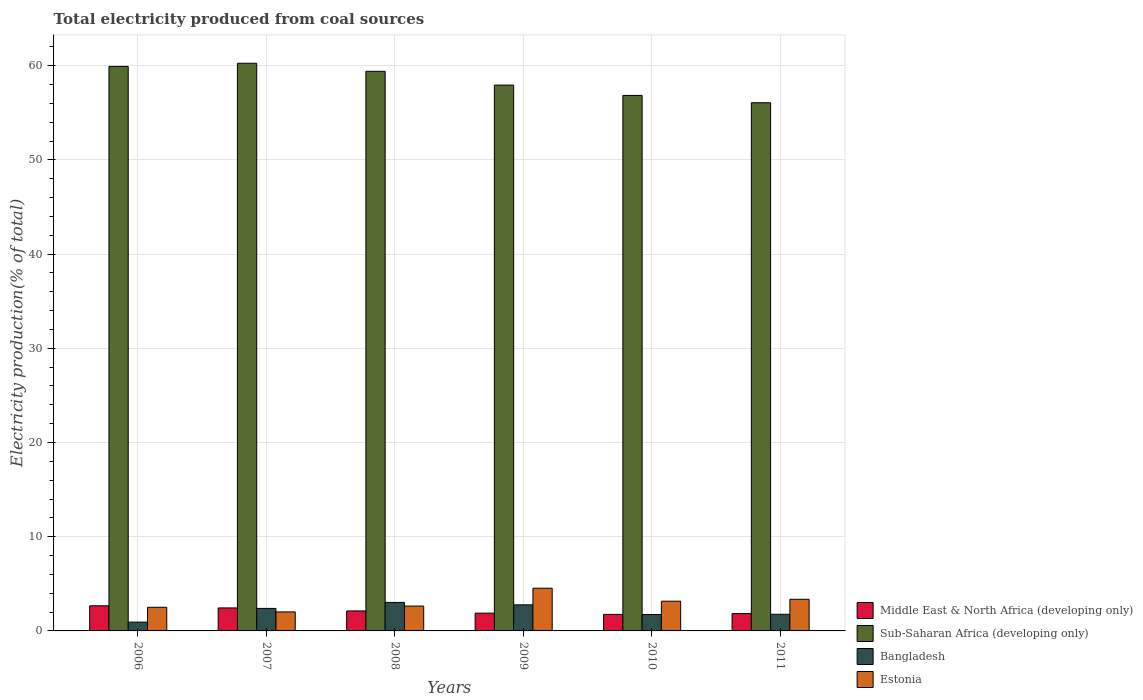How many groups of bars are there?
Offer a terse response. 6. Are the number of bars per tick equal to the number of legend labels?
Your answer should be compact. Yes. How many bars are there on the 1st tick from the left?
Your answer should be very brief. 4. What is the label of the 3rd group of bars from the left?
Offer a terse response. 2008. What is the total electricity produced in Middle East & North Africa (developing only) in 2007?
Offer a terse response. 2.44. Across all years, what is the maximum total electricity produced in Estonia?
Your answer should be compact. 4.53. Across all years, what is the minimum total electricity produced in Bangladesh?
Give a very brief answer. 0.93. In which year was the total electricity produced in Bangladesh maximum?
Keep it short and to the point. 2008. In which year was the total electricity produced in Estonia minimum?
Your answer should be very brief. 2007. What is the total total electricity produced in Middle East & North Africa (developing only) in the graph?
Offer a very short reply. 12.72. What is the difference between the total electricity produced in Middle East & North Africa (developing only) in 2009 and that in 2011?
Ensure brevity in your answer.  0.05. What is the difference between the total electricity produced in Middle East & North Africa (developing only) in 2011 and the total electricity produced in Estonia in 2010?
Offer a very short reply. -1.31. What is the average total electricity produced in Estonia per year?
Make the answer very short. 3.03. In the year 2007, what is the difference between the total electricity produced in Bangladesh and total electricity produced in Middle East & North Africa (developing only)?
Offer a very short reply. -0.05. In how many years, is the total electricity produced in Bangladesh greater than 38 %?
Offer a terse response. 0. What is the ratio of the total electricity produced in Sub-Saharan Africa (developing only) in 2008 to that in 2010?
Provide a succinct answer. 1.05. Is the total electricity produced in Sub-Saharan Africa (developing only) in 2006 less than that in 2010?
Give a very brief answer. No. What is the difference between the highest and the second highest total electricity produced in Bangladesh?
Keep it short and to the point. 0.25. What is the difference between the highest and the lowest total electricity produced in Sub-Saharan Africa (developing only)?
Offer a very short reply. 4.19. Is the sum of the total electricity produced in Bangladesh in 2010 and 2011 greater than the maximum total electricity produced in Sub-Saharan Africa (developing only) across all years?
Offer a terse response. No. What does the 2nd bar from the left in 2011 represents?
Keep it short and to the point. Sub-Saharan Africa (developing only). What does the 4th bar from the right in 2007 represents?
Your answer should be very brief. Middle East & North Africa (developing only). Where does the legend appear in the graph?
Provide a succinct answer. Bottom right. How many legend labels are there?
Give a very brief answer. 4. What is the title of the graph?
Your response must be concise. Total electricity produced from coal sources. Does "Hong Kong" appear as one of the legend labels in the graph?
Give a very brief answer. No. What is the label or title of the X-axis?
Your answer should be compact. Years. What is the Electricity production(% of total) in Middle East & North Africa (developing only) in 2006?
Provide a short and direct response. 2.67. What is the Electricity production(% of total) in Sub-Saharan Africa (developing only) in 2006?
Your answer should be compact. 59.92. What is the Electricity production(% of total) of Bangladesh in 2006?
Keep it short and to the point. 0.93. What is the Electricity production(% of total) in Estonia in 2006?
Give a very brief answer. 2.51. What is the Electricity production(% of total) of Middle East & North Africa (developing only) in 2007?
Give a very brief answer. 2.44. What is the Electricity production(% of total) in Sub-Saharan Africa (developing only) in 2007?
Your answer should be compact. 60.25. What is the Electricity production(% of total) of Bangladesh in 2007?
Keep it short and to the point. 2.39. What is the Electricity production(% of total) of Estonia in 2007?
Offer a terse response. 2.02. What is the Electricity production(% of total) in Middle East & North Africa (developing only) in 2008?
Offer a terse response. 2.12. What is the Electricity production(% of total) of Sub-Saharan Africa (developing only) in 2008?
Your response must be concise. 59.4. What is the Electricity production(% of total) in Bangladesh in 2008?
Your answer should be compact. 3.02. What is the Electricity production(% of total) of Estonia in 2008?
Give a very brief answer. 2.64. What is the Electricity production(% of total) in Middle East & North Africa (developing only) in 2009?
Offer a very short reply. 1.89. What is the Electricity production(% of total) of Sub-Saharan Africa (developing only) in 2009?
Give a very brief answer. 57.94. What is the Electricity production(% of total) of Bangladesh in 2009?
Make the answer very short. 2.77. What is the Electricity production(% of total) of Estonia in 2009?
Your answer should be compact. 4.53. What is the Electricity production(% of total) of Middle East & North Africa (developing only) in 2010?
Ensure brevity in your answer.  1.76. What is the Electricity production(% of total) of Sub-Saharan Africa (developing only) in 2010?
Your answer should be very brief. 56.84. What is the Electricity production(% of total) in Bangladesh in 2010?
Your answer should be very brief. 1.74. What is the Electricity production(% of total) of Estonia in 2010?
Ensure brevity in your answer.  3.15. What is the Electricity production(% of total) in Middle East & North Africa (developing only) in 2011?
Your answer should be compact. 1.84. What is the Electricity production(% of total) of Sub-Saharan Africa (developing only) in 2011?
Provide a short and direct response. 56.06. What is the Electricity production(% of total) in Bangladesh in 2011?
Ensure brevity in your answer.  1.77. What is the Electricity production(% of total) in Estonia in 2011?
Your answer should be very brief. 3.36. Across all years, what is the maximum Electricity production(% of total) of Middle East & North Africa (developing only)?
Your answer should be compact. 2.67. Across all years, what is the maximum Electricity production(% of total) in Sub-Saharan Africa (developing only)?
Offer a terse response. 60.25. Across all years, what is the maximum Electricity production(% of total) of Bangladesh?
Provide a succinct answer. 3.02. Across all years, what is the maximum Electricity production(% of total) in Estonia?
Provide a succinct answer. 4.53. Across all years, what is the minimum Electricity production(% of total) in Middle East & North Africa (developing only)?
Give a very brief answer. 1.76. Across all years, what is the minimum Electricity production(% of total) of Sub-Saharan Africa (developing only)?
Offer a terse response. 56.06. Across all years, what is the minimum Electricity production(% of total) of Bangladesh?
Provide a succinct answer. 0.93. Across all years, what is the minimum Electricity production(% of total) of Estonia?
Offer a terse response. 2.02. What is the total Electricity production(% of total) of Middle East & North Africa (developing only) in the graph?
Offer a very short reply. 12.72. What is the total Electricity production(% of total) of Sub-Saharan Africa (developing only) in the graph?
Offer a very short reply. 350.42. What is the total Electricity production(% of total) of Bangladesh in the graph?
Keep it short and to the point. 12.63. What is the total Electricity production(% of total) in Estonia in the graph?
Ensure brevity in your answer.  18.21. What is the difference between the Electricity production(% of total) of Middle East & North Africa (developing only) in 2006 and that in 2007?
Provide a succinct answer. 0.23. What is the difference between the Electricity production(% of total) in Sub-Saharan Africa (developing only) in 2006 and that in 2007?
Offer a terse response. -0.33. What is the difference between the Electricity production(% of total) in Bangladesh in 2006 and that in 2007?
Offer a terse response. -1.46. What is the difference between the Electricity production(% of total) of Estonia in 2006 and that in 2007?
Your answer should be very brief. 0.49. What is the difference between the Electricity production(% of total) in Middle East & North Africa (developing only) in 2006 and that in 2008?
Offer a very short reply. 0.55. What is the difference between the Electricity production(% of total) of Sub-Saharan Africa (developing only) in 2006 and that in 2008?
Offer a terse response. 0.52. What is the difference between the Electricity production(% of total) in Bangladesh in 2006 and that in 2008?
Provide a succinct answer. -2.09. What is the difference between the Electricity production(% of total) of Estonia in 2006 and that in 2008?
Offer a terse response. -0.13. What is the difference between the Electricity production(% of total) of Middle East & North Africa (developing only) in 2006 and that in 2009?
Provide a succinct answer. 0.78. What is the difference between the Electricity production(% of total) in Sub-Saharan Africa (developing only) in 2006 and that in 2009?
Your answer should be compact. 1.98. What is the difference between the Electricity production(% of total) in Bangladesh in 2006 and that in 2009?
Make the answer very short. -1.84. What is the difference between the Electricity production(% of total) in Estonia in 2006 and that in 2009?
Keep it short and to the point. -2.03. What is the difference between the Electricity production(% of total) in Middle East & North Africa (developing only) in 2006 and that in 2010?
Make the answer very short. 0.91. What is the difference between the Electricity production(% of total) of Sub-Saharan Africa (developing only) in 2006 and that in 2010?
Your answer should be compact. 3.08. What is the difference between the Electricity production(% of total) in Bangladesh in 2006 and that in 2010?
Offer a very short reply. -0.81. What is the difference between the Electricity production(% of total) of Estonia in 2006 and that in 2010?
Give a very brief answer. -0.65. What is the difference between the Electricity production(% of total) in Middle East & North Africa (developing only) in 2006 and that in 2011?
Your answer should be compact. 0.83. What is the difference between the Electricity production(% of total) of Sub-Saharan Africa (developing only) in 2006 and that in 2011?
Give a very brief answer. 3.86. What is the difference between the Electricity production(% of total) in Bangladesh in 2006 and that in 2011?
Make the answer very short. -0.83. What is the difference between the Electricity production(% of total) in Estonia in 2006 and that in 2011?
Your answer should be compact. -0.85. What is the difference between the Electricity production(% of total) of Middle East & North Africa (developing only) in 2007 and that in 2008?
Your answer should be compact. 0.32. What is the difference between the Electricity production(% of total) in Sub-Saharan Africa (developing only) in 2007 and that in 2008?
Offer a very short reply. 0.85. What is the difference between the Electricity production(% of total) in Bangladesh in 2007 and that in 2008?
Offer a terse response. -0.64. What is the difference between the Electricity production(% of total) in Estonia in 2007 and that in 2008?
Provide a succinct answer. -0.62. What is the difference between the Electricity production(% of total) in Middle East & North Africa (developing only) in 2007 and that in 2009?
Your answer should be very brief. 0.55. What is the difference between the Electricity production(% of total) in Sub-Saharan Africa (developing only) in 2007 and that in 2009?
Provide a short and direct response. 2.32. What is the difference between the Electricity production(% of total) of Bangladesh in 2007 and that in 2009?
Provide a short and direct response. -0.38. What is the difference between the Electricity production(% of total) of Estonia in 2007 and that in 2009?
Offer a very short reply. -2.52. What is the difference between the Electricity production(% of total) in Middle East & North Africa (developing only) in 2007 and that in 2010?
Make the answer very short. 0.69. What is the difference between the Electricity production(% of total) in Sub-Saharan Africa (developing only) in 2007 and that in 2010?
Offer a terse response. 3.41. What is the difference between the Electricity production(% of total) in Bangladesh in 2007 and that in 2010?
Give a very brief answer. 0.65. What is the difference between the Electricity production(% of total) of Estonia in 2007 and that in 2010?
Offer a terse response. -1.14. What is the difference between the Electricity production(% of total) of Middle East & North Africa (developing only) in 2007 and that in 2011?
Keep it short and to the point. 0.6. What is the difference between the Electricity production(% of total) in Sub-Saharan Africa (developing only) in 2007 and that in 2011?
Provide a short and direct response. 4.19. What is the difference between the Electricity production(% of total) of Bangladesh in 2007 and that in 2011?
Offer a terse response. 0.62. What is the difference between the Electricity production(% of total) of Estonia in 2007 and that in 2011?
Keep it short and to the point. -1.34. What is the difference between the Electricity production(% of total) in Middle East & North Africa (developing only) in 2008 and that in 2009?
Your answer should be very brief. 0.23. What is the difference between the Electricity production(% of total) in Sub-Saharan Africa (developing only) in 2008 and that in 2009?
Keep it short and to the point. 1.46. What is the difference between the Electricity production(% of total) in Bangladesh in 2008 and that in 2009?
Offer a very short reply. 0.25. What is the difference between the Electricity production(% of total) in Estonia in 2008 and that in 2009?
Your answer should be very brief. -1.9. What is the difference between the Electricity production(% of total) in Middle East & North Africa (developing only) in 2008 and that in 2010?
Provide a short and direct response. 0.37. What is the difference between the Electricity production(% of total) in Sub-Saharan Africa (developing only) in 2008 and that in 2010?
Provide a succinct answer. 2.56. What is the difference between the Electricity production(% of total) in Bangladesh in 2008 and that in 2010?
Offer a very short reply. 1.28. What is the difference between the Electricity production(% of total) of Estonia in 2008 and that in 2010?
Your answer should be compact. -0.52. What is the difference between the Electricity production(% of total) in Middle East & North Africa (developing only) in 2008 and that in 2011?
Keep it short and to the point. 0.28. What is the difference between the Electricity production(% of total) in Sub-Saharan Africa (developing only) in 2008 and that in 2011?
Keep it short and to the point. 3.34. What is the difference between the Electricity production(% of total) of Bangladesh in 2008 and that in 2011?
Offer a very short reply. 1.26. What is the difference between the Electricity production(% of total) in Estonia in 2008 and that in 2011?
Your answer should be compact. -0.72. What is the difference between the Electricity production(% of total) in Middle East & North Africa (developing only) in 2009 and that in 2010?
Make the answer very short. 0.13. What is the difference between the Electricity production(% of total) of Sub-Saharan Africa (developing only) in 2009 and that in 2010?
Offer a very short reply. 1.1. What is the difference between the Electricity production(% of total) of Bangladesh in 2009 and that in 2010?
Give a very brief answer. 1.03. What is the difference between the Electricity production(% of total) of Estonia in 2009 and that in 2010?
Your response must be concise. 1.38. What is the difference between the Electricity production(% of total) of Middle East & North Africa (developing only) in 2009 and that in 2011?
Ensure brevity in your answer.  0.05. What is the difference between the Electricity production(% of total) of Sub-Saharan Africa (developing only) in 2009 and that in 2011?
Your answer should be very brief. 1.87. What is the difference between the Electricity production(% of total) in Bangladesh in 2009 and that in 2011?
Provide a short and direct response. 1. What is the difference between the Electricity production(% of total) of Estonia in 2009 and that in 2011?
Offer a very short reply. 1.18. What is the difference between the Electricity production(% of total) in Middle East & North Africa (developing only) in 2010 and that in 2011?
Give a very brief answer. -0.09. What is the difference between the Electricity production(% of total) in Sub-Saharan Africa (developing only) in 2010 and that in 2011?
Give a very brief answer. 0.78. What is the difference between the Electricity production(% of total) in Bangladesh in 2010 and that in 2011?
Make the answer very short. -0.02. What is the difference between the Electricity production(% of total) in Estonia in 2010 and that in 2011?
Give a very brief answer. -0.2. What is the difference between the Electricity production(% of total) of Middle East & North Africa (developing only) in 2006 and the Electricity production(% of total) of Sub-Saharan Africa (developing only) in 2007?
Provide a succinct answer. -57.59. What is the difference between the Electricity production(% of total) in Middle East & North Africa (developing only) in 2006 and the Electricity production(% of total) in Bangladesh in 2007?
Your answer should be very brief. 0.28. What is the difference between the Electricity production(% of total) of Middle East & North Africa (developing only) in 2006 and the Electricity production(% of total) of Estonia in 2007?
Provide a short and direct response. 0.65. What is the difference between the Electricity production(% of total) of Sub-Saharan Africa (developing only) in 2006 and the Electricity production(% of total) of Bangladesh in 2007?
Ensure brevity in your answer.  57.53. What is the difference between the Electricity production(% of total) of Sub-Saharan Africa (developing only) in 2006 and the Electricity production(% of total) of Estonia in 2007?
Ensure brevity in your answer.  57.9. What is the difference between the Electricity production(% of total) in Bangladesh in 2006 and the Electricity production(% of total) in Estonia in 2007?
Provide a succinct answer. -1.08. What is the difference between the Electricity production(% of total) in Middle East & North Africa (developing only) in 2006 and the Electricity production(% of total) in Sub-Saharan Africa (developing only) in 2008?
Provide a succinct answer. -56.73. What is the difference between the Electricity production(% of total) in Middle East & North Africa (developing only) in 2006 and the Electricity production(% of total) in Bangladesh in 2008?
Provide a short and direct response. -0.36. What is the difference between the Electricity production(% of total) of Middle East & North Africa (developing only) in 2006 and the Electricity production(% of total) of Estonia in 2008?
Provide a succinct answer. 0.03. What is the difference between the Electricity production(% of total) of Sub-Saharan Africa (developing only) in 2006 and the Electricity production(% of total) of Bangladesh in 2008?
Your answer should be compact. 56.9. What is the difference between the Electricity production(% of total) of Sub-Saharan Africa (developing only) in 2006 and the Electricity production(% of total) of Estonia in 2008?
Provide a succinct answer. 57.28. What is the difference between the Electricity production(% of total) of Bangladesh in 2006 and the Electricity production(% of total) of Estonia in 2008?
Your response must be concise. -1.7. What is the difference between the Electricity production(% of total) in Middle East & North Africa (developing only) in 2006 and the Electricity production(% of total) in Sub-Saharan Africa (developing only) in 2009?
Make the answer very short. -55.27. What is the difference between the Electricity production(% of total) in Middle East & North Africa (developing only) in 2006 and the Electricity production(% of total) in Bangladesh in 2009?
Offer a very short reply. -0.1. What is the difference between the Electricity production(% of total) of Middle East & North Africa (developing only) in 2006 and the Electricity production(% of total) of Estonia in 2009?
Ensure brevity in your answer.  -1.87. What is the difference between the Electricity production(% of total) in Sub-Saharan Africa (developing only) in 2006 and the Electricity production(% of total) in Bangladesh in 2009?
Your answer should be very brief. 57.15. What is the difference between the Electricity production(% of total) in Sub-Saharan Africa (developing only) in 2006 and the Electricity production(% of total) in Estonia in 2009?
Offer a very short reply. 55.39. What is the difference between the Electricity production(% of total) in Bangladesh in 2006 and the Electricity production(% of total) in Estonia in 2009?
Provide a succinct answer. -3.6. What is the difference between the Electricity production(% of total) in Middle East & North Africa (developing only) in 2006 and the Electricity production(% of total) in Sub-Saharan Africa (developing only) in 2010?
Provide a succinct answer. -54.17. What is the difference between the Electricity production(% of total) in Middle East & North Africa (developing only) in 2006 and the Electricity production(% of total) in Bangladesh in 2010?
Offer a terse response. 0.92. What is the difference between the Electricity production(% of total) in Middle East & North Africa (developing only) in 2006 and the Electricity production(% of total) in Estonia in 2010?
Give a very brief answer. -0.49. What is the difference between the Electricity production(% of total) of Sub-Saharan Africa (developing only) in 2006 and the Electricity production(% of total) of Bangladesh in 2010?
Provide a succinct answer. 58.18. What is the difference between the Electricity production(% of total) in Sub-Saharan Africa (developing only) in 2006 and the Electricity production(% of total) in Estonia in 2010?
Offer a terse response. 56.77. What is the difference between the Electricity production(% of total) of Bangladesh in 2006 and the Electricity production(% of total) of Estonia in 2010?
Provide a succinct answer. -2.22. What is the difference between the Electricity production(% of total) in Middle East & North Africa (developing only) in 2006 and the Electricity production(% of total) in Sub-Saharan Africa (developing only) in 2011?
Your answer should be compact. -53.4. What is the difference between the Electricity production(% of total) of Middle East & North Africa (developing only) in 2006 and the Electricity production(% of total) of Bangladesh in 2011?
Your answer should be very brief. 0.9. What is the difference between the Electricity production(% of total) in Middle East & North Africa (developing only) in 2006 and the Electricity production(% of total) in Estonia in 2011?
Make the answer very short. -0.69. What is the difference between the Electricity production(% of total) of Sub-Saharan Africa (developing only) in 2006 and the Electricity production(% of total) of Bangladesh in 2011?
Offer a very short reply. 58.15. What is the difference between the Electricity production(% of total) of Sub-Saharan Africa (developing only) in 2006 and the Electricity production(% of total) of Estonia in 2011?
Make the answer very short. 56.56. What is the difference between the Electricity production(% of total) in Bangladesh in 2006 and the Electricity production(% of total) in Estonia in 2011?
Offer a very short reply. -2.42. What is the difference between the Electricity production(% of total) of Middle East & North Africa (developing only) in 2007 and the Electricity production(% of total) of Sub-Saharan Africa (developing only) in 2008?
Provide a succinct answer. -56.96. What is the difference between the Electricity production(% of total) in Middle East & North Africa (developing only) in 2007 and the Electricity production(% of total) in Bangladesh in 2008?
Provide a short and direct response. -0.58. What is the difference between the Electricity production(% of total) of Middle East & North Africa (developing only) in 2007 and the Electricity production(% of total) of Estonia in 2008?
Your answer should be very brief. -0.2. What is the difference between the Electricity production(% of total) of Sub-Saharan Africa (developing only) in 2007 and the Electricity production(% of total) of Bangladesh in 2008?
Provide a short and direct response. 57.23. What is the difference between the Electricity production(% of total) in Sub-Saharan Africa (developing only) in 2007 and the Electricity production(% of total) in Estonia in 2008?
Give a very brief answer. 57.62. What is the difference between the Electricity production(% of total) in Bangladesh in 2007 and the Electricity production(% of total) in Estonia in 2008?
Your answer should be very brief. -0.25. What is the difference between the Electricity production(% of total) of Middle East & North Africa (developing only) in 2007 and the Electricity production(% of total) of Sub-Saharan Africa (developing only) in 2009?
Ensure brevity in your answer.  -55.5. What is the difference between the Electricity production(% of total) in Middle East & North Africa (developing only) in 2007 and the Electricity production(% of total) in Bangladesh in 2009?
Give a very brief answer. -0.33. What is the difference between the Electricity production(% of total) of Middle East & North Africa (developing only) in 2007 and the Electricity production(% of total) of Estonia in 2009?
Your response must be concise. -2.09. What is the difference between the Electricity production(% of total) in Sub-Saharan Africa (developing only) in 2007 and the Electricity production(% of total) in Bangladesh in 2009?
Make the answer very short. 57.49. What is the difference between the Electricity production(% of total) of Sub-Saharan Africa (developing only) in 2007 and the Electricity production(% of total) of Estonia in 2009?
Your answer should be compact. 55.72. What is the difference between the Electricity production(% of total) of Bangladesh in 2007 and the Electricity production(% of total) of Estonia in 2009?
Provide a short and direct response. -2.14. What is the difference between the Electricity production(% of total) in Middle East & North Africa (developing only) in 2007 and the Electricity production(% of total) in Sub-Saharan Africa (developing only) in 2010?
Make the answer very short. -54.4. What is the difference between the Electricity production(% of total) of Middle East & North Africa (developing only) in 2007 and the Electricity production(% of total) of Bangladesh in 2010?
Provide a succinct answer. 0.7. What is the difference between the Electricity production(% of total) of Middle East & North Africa (developing only) in 2007 and the Electricity production(% of total) of Estonia in 2010?
Your answer should be compact. -0.71. What is the difference between the Electricity production(% of total) in Sub-Saharan Africa (developing only) in 2007 and the Electricity production(% of total) in Bangladesh in 2010?
Your answer should be compact. 58.51. What is the difference between the Electricity production(% of total) of Sub-Saharan Africa (developing only) in 2007 and the Electricity production(% of total) of Estonia in 2010?
Give a very brief answer. 57.1. What is the difference between the Electricity production(% of total) in Bangladesh in 2007 and the Electricity production(% of total) in Estonia in 2010?
Provide a short and direct response. -0.77. What is the difference between the Electricity production(% of total) of Middle East & North Africa (developing only) in 2007 and the Electricity production(% of total) of Sub-Saharan Africa (developing only) in 2011?
Ensure brevity in your answer.  -53.62. What is the difference between the Electricity production(% of total) of Middle East & North Africa (developing only) in 2007 and the Electricity production(% of total) of Bangladesh in 2011?
Offer a terse response. 0.68. What is the difference between the Electricity production(% of total) of Middle East & North Africa (developing only) in 2007 and the Electricity production(% of total) of Estonia in 2011?
Give a very brief answer. -0.92. What is the difference between the Electricity production(% of total) of Sub-Saharan Africa (developing only) in 2007 and the Electricity production(% of total) of Bangladesh in 2011?
Your answer should be very brief. 58.49. What is the difference between the Electricity production(% of total) in Sub-Saharan Africa (developing only) in 2007 and the Electricity production(% of total) in Estonia in 2011?
Give a very brief answer. 56.9. What is the difference between the Electricity production(% of total) of Bangladesh in 2007 and the Electricity production(% of total) of Estonia in 2011?
Make the answer very short. -0.97. What is the difference between the Electricity production(% of total) of Middle East & North Africa (developing only) in 2008 and the Electricity production(% of total) of Sub-Saharan Africa (developing only) in 2009?
Your response must be concise. -55.82. What is the difference between the Electricity production(% of total) of Middle East & North Africa (developing only) in 2008 and the Electricity production(% of total) of Bangladesh in 2009?
Offer a very short reply. -0.65. What is the difference between the Electricity production(% of total) of Middle East & North Africa (developing only) in 2008 and the Electricity production(% of total) of Estonia in 2009?
Your answer should be compact. -2.41. What is the difference between the Electricity production(% of total) in Sub-Saharan Africa (developing only) in 2008 and the Electricity production(% of total) in Bangladesh in 2009?
Offer a terse response. 56.63. What is the difference between the Electricity production(% of total) in Sub-Saharan Africa (developing only) in 2008 and the Electricity production(% of total) in Estonia in 2009?
Give a very brief answer. 54.87. What is the difference between the Electricity production(% of total) of Bangladesh in 2008 and the Electricity production(% of total) of Estonia in 2009?
Provide a succinct answer. -1.51. What is the difference between the Electricity production(% of total) in Middle East & North Africa (developing only) in 2008 and the Electricity production(% of total) in Sub-Saharan Africa (developing only) in 2010?
Provide a succinct answer. -54.72. What is the difference between the Electricity production(% of total) of Middle East & North Africa (developing only) in 2008 and the Electricity production(% of total) of Bangladesh in 2010?
Your response must be concise. 0.38. What is the difference between the Electricity production(% of total) of Middle East & North Africa (developing only) in 2008 and the Electricity production(% of total) of Estonia in 2010?
Your response must be concise. -1.03. What is the difference between the Electricity production(% of total) of Sub-Saharan Africa (developing only) in 2008 and the Electricity production(% of total) of Bangladesh in 2010?
Your answer should be very brief. 57.66. What is the difference between the Electricity production(% of total) in Sub-Saharan Africa (developing only) in 2008 and the Electricity production(% of total) in Estonia in 2010?
Your answer should be compact. 56.25. What is the difference between the Electricity production(% of total) of Bangladesh in 2008 and the Electricity production(% of total) of Estonia in 2010?
Provide a succinct answer. -0.13. What is the difference between the Electricity production(% of total) of Middle East & North Africa (developing only) in 2008 and the Electricity production(% of total) of Sub-Saharan Africa (developing only) in 2011?
Your answer should be very brief. -53.94. What is the difference between the Electricity production(% of total) in Middle East & North Africa (developing only) in 2008 and the Electricity production(% of total) in Bangladesh in 2011?
Your answer should be compact. 0.36. What is the difference between the Electricity production(% of total) of Middle East & North Africa (developing only) in 2008 and the Electricity production(% of total) of Estonia in 2011?
Offer a very short reply. -1.24. What is the difference between the Electricity production(% of total) in Sub-Saharan Africa (developing only) in 2008 and the Electricity production(% of total) in Bangladesh in 2011?
Keep it short and to the point. 57.63. What is the difference between the Electricity production(% of total) in Sub-Saharan Africa (developing only) in 2008 and the Electricity production(% of total) in Estonia in 2011?
Provide a succinct answer. 56.04. What is the difference between the Electricity production(% of total) of Bangladesh in 2008 and the Electricity production(% of total) of Estonia in 2011?
Offer a terse response. -0.33. What is the difference between the Electricity production(% of total) in Middle East & North Africa (developing only) in 2009 and the Electricity production(% of total) in Sub-Saharan Africa (developing only) in 2010?
Your response must be concise. -54.95. What is the difference between the Electricity production(% of total) of Middle East & North Africa (developing only) in 2009 and the Electricity production(% of total) of Bangladesh in 2010?
Offer a terse response. 0.14. What is the difference between the Electricity production(% of total) in Middle East & North Africa (developing only) in 2009 and the Electricity production(% of total) in Estonia in 2010?
Give a very brief answer. -1.27. What is the difference between the Electricity production(% of total) in Sub-Saharan Africa (developing only) in 2009 and the Electricity production(% of total) in Bangladesh in 2010?
Make the answer very short. 56.19. What is the difference between the Electricity production(% of total) in Sub-Saharan Africa (developing only) in 2009 and the Electricity production(% of total) in Estonia in 2010?
Your response must be concise. 54.78. What is the difference between the Electricity production(% of total) in Bangladesh in 2009 and the Electricity production(% of total) in Estonia in 2010?
Make the answer very short. -0.39. What is the difference between the Electricity production(% of total) of Middle East & North Africa (developing only) in 2009 and the Electricity production(% of total) of Sub-Saharan Africa (developing only) in 2011?
Your answer should be very brief. -54.18. What is the difference between the Electricity production(% of total) in Middle East & North Africa (developing only) in 2009 and the Electricity production(% of total) in Bangladesh in 2011?
Offer a terse response. 0.12. What is the difference between the Electricity production(% of total) in Middle East & North Africa (developing only) in 2009 and the Electricity production(% of total) in Estonia in 2011?
Make the answer very short. -1.47. What is the difference between the Electricity production(% of total) of Sub-Saharan Africa (developing only) in 2009 and the Electricity production(% of total) of Bangladesh in 2011?
Offer a very short reply. 56.17. What is the difference between the Electricity production(% of total) of Sub-Saharan Africa (developing only) in 2009 and the Electricity production(% of total) of Estonia in 2011?
Provide a short and direct response. 54.58. What is the difference between the Electricity production(% of total) of Bangladesh in 2009 and the Electricity production(% of total) of Estonia in 2011?
Offer a terse response. -0.59. What is the difference between the Electricity production(% of total) in Middle East & North Africa (developing only) in 2010 and the Electricity production(% of total) in Sub-Saharan Africa (developing only) in 2011?
Provide a short and direct response. -54.31. What is the difference between the Electricity production(% of total) of Middle East & North Africa (developing only) in 2010 and the Electricity production(% of total) of Bangladesh in 2011?
Provide a short and direct response. -0.01. What is the difference between the Electricity production(% of total) of Middle East & North Africa (developing only) in 2010 and the Electricity production(% of total) of Estonia in 2011?
Provide a succinct answer. -1.6. What is the difference between the Electricity production(% of total) of Sub-Saharan Africa (developing only) in 2010 and the Electricity production(% of total) of Bangladesh in 2011?
Offer a very short reply. 55.08. What is the difference between the Electricity production(% of total) of Sub-Saharan Africa (developing only) in 2010 and the Electricity production(% of total) of Estonia in 2011?
Make the answer very short. 53.48. What is the difference between the Electricity production(% of total) in Bangladesh in 2010 and the Electricity production(% of total) in Estonia in 2011?
Make the answer very short. -1.61. What is the average Electricity production(% of total) of Middle East & North Africa (developing only) per year?
Ensure brevity in your answer.  2.12. What is the average Electricity production(% of total) in Sub-Saharan Africa (developing only) per year?
Your answer should be compact. 58.4. What is the average Electricity production(% of total) of Bangladesh per year?
Provide a short and direct response. 2.1. What is the average Electricity production(% of total) in Estonia per year?
Keep it short and to the point. 3.03. In the year 2006, what is the difference between the Electricity production(% of total) of Middle East & North Africa (developing only) and Electricity production(% of total) of Sub-Saharan Africa (developing only)?
Give a very brief answer. -57.25. In the year 2006, what is the difference between the Electricity production(% of total) of Middle East & North Africa (developing only) and Electricity production(% of total) of Bangladesh?
Ensure brevity in your answer.  1.73. In the year 2006, what is the difference between the Electricity production(% of total) of Middle East & North Africa (developing only) and Electricity production(% of total) of Estonia?
Ensure brevity in your answer.  0.16. In the year 2006, what is the difference between the Electricity production(% of total) in Sub-Saharan Africa (developing only) and Electricity production(% of total) in Bangladesh?
Give a very brief answer. 58.99. In the year 2006, what is the difference between the Electricity production(% of total) of Sub-Saharan Africa (developing only) and Electricity production(% of total) of Estonia?
Ensure brevity in your answer.  57.41. In the year 2006, what is the difference between the Electricity production(% of total) of Bangladesh and Electricity production(% of total) of Estonia?
Make the answer very short. -1.57. In the year 2007, what is the difference between the Electricity production(% of total) in Middle East & North Africa (developing only) and Electricity production(% of total) in Sub-Saharan Africa (developing only)?
Make the answer very short. -57.81. In the year 2007, what is the difference between the Electricity production(% of total) in Middle East & North Africa (developing only) and Electricity production(% of total) in Bangladesh?
Your answer should be compact. 0.05. In the year 2007, what is the difference between the Electricity production(% of total) of Middle East & North Africa (developing only) and Electricity production(% of total) of Estonia?
Provide a short and direct response. 0.42. In the year 2007, what is the difference between the Electricity production(% of total) of Sub-Saharan Africa (developing only) and Electricity production(% of total) of Bangladesh?
Ensure brevity in your answer.  57.87. In the year 2007, what is the difference between the Electricity production(% of total) in Sub-Saharan Africa (developing only) and Electricity production(% of total) in Estonia?
Ensure brevity in your answer.  58.24. In the year 2007, what is the difference between the Electricity production(% of total) of Bangladesh and Electricity production(% of total) of Estonia?
Provide a succinct answer. 0.37. In the year 2008, what is the difference between the Electricity production(% of total) of Middle East & North Africa (developing only) and Electricity production(% of total) of Sub-Saharan Africa (developing only)?
Provide a short and direct response. -57.28. In the year 2008, what is the difference between the Electricity production(% of total) in Middle East & North Africa (developing only) and Electricity production(% of total) in Bangladesh?
Your response must be concise. -0.9. In the year 2008, what is the difference between the Electricity production(% of total) of Middle East & North Africa (developing only) and Electricity production(% of total) of Estonia?
Offer a terse response. -0.52. In the year 2008, what is the difference between the Electricity production(% of total) of Sub-Saharan Africa (developing only) and Electricity production(% of total) of Bangladesh?
Offer a terse response. 56.38. In the year 2008, what is the difference between the Electricity production(% of total) in Sub-Saharan Africa (developing only) and Electricity production(% of total) in Estonia?
Offer a very short reply. 56.76. In the year 2008, what is the difference between the Electricity production(% of total) in Bangladesh and Electricity production(% of total) in Estonia?
Provide a short and direct response. 0.39. In the year 2009, what is the difference between the Electricity production(% of total) of Middle East & North Africa (developing only) and Electricity production(% of total) of Sub-Saharan Africa (developing only)?
Keep it short and to the point. -56.05. In the year 2009, what is the difference between the Electricity production(% of total) in Middle East & North Africa (developing only) and Electricity production(% of total) in Bangladesh?
Provide a short and direct response. -0.88. In the year 2009, what is the difference between the Electricity production(% of total) in Middle East & North Africa (developing only) and Electricity production(% of total) in Estonia?
Provide a short and direct response. -2.65. In the year 2009, what is the difference between the Electricity production(% of total) in Sub-Saharan Africa (developing only) and Electricity production(% of total) in Bangladesh?
Keep it short and to the point. 55.17. In the year 2009, what is the difference between the Electricity production(% of total) in Sub-Saharan Africa (developing only) and Electricity production(% of total) in Estonia?
Keep it short and to the point. 53.4. In the year 2009, what is the difference between the Electricity production(% of total) of Bangladesh and Electricity production(% of total) of Estonia?
Your answer should be compact. -1.76. In the year 2010, what is the difference between the Electricity production(% of total) in Middle East & North Africa (developing only) and Electricity production(% of total) in Sub-Saharan Africa (developing only)?
Offer a very short reply. -55.09. In the year 2010, what is the difference between the Electricity production(% of total) of Middle East & North Africa (developing only) and Electricity production(% of total) of Bangladesh?
Ensure brevity in your answer.  0.01. In the year 2010, what is the difference between the Electricity production(% of total) of Middle East & North Africa (developing only) and Electricity production(% of total) of Estonia?
Provide a succinct answer. -1.4. In the year 2010, what is the difference between the Electricity production(% of total) in Sub-Saharan Africa (developing only) and Electricity production(% of total) in Bangladesh?
Your answer should be compact. 55.1. In the year 2010, what is the difference between the Electricity production(% of total) of Sub-Saharan Africa (developing only) and Electricity production(% of total) of Estonia?
Your answer should be very brief. 53.69. In the year 2010, what is the difference between the Electricity production(% of total) of Bangladesh and Electricity production(% of total) of Estonia?
Provide a short and direct response. -1.41. In the year 2011, what is the difference between the Electricity production(% of total) in Middle East & North Africa (developing only) and Electricity production(% of total) in Sub-Saharan Africa (developing only)?
Ensure brevity in your answer.  -54.22. In the year 2011, what is the difference between the Electricity production(% of total) in Middle East & North Africa (developing only) and Electricity production(% of total) in Bangladesh?
Offer a very short reply. 0.08. In the year 2011, what is the difference between the Electricity production(% of total) of Middle East & North Africa (developing only) and Electricity production(% of total) of Estonia?
Your answer should be compact. -1.52. In the year 2011, what is the difference between the Electricity production(% of total) of Sub-Saharan Africa (developing only) and Electricity production(% of total) of Bangladesh?
Ensure brevity in your answer.  54.3. In the year 2011, what is the difference between the Electricity production(% of total) of Sub-Saharan Africa (developing only) and Electricity production(% of total) of Estonia?
Make the answer very short. 52.71. In the year 2011, what is the difference between the Electricity production(% of total) in Bangladesh and Electricity production(% of total) in Estonia?
Offer a terse response. -1.59. What is the ratio of the Electricity production(% of total) of Middle East & North Africa (developing only) in 2006 to that in 2007?
Provide a short and direct response. 1.09. What is the ratio of the Electricity production(% of total) of Sub-Saharan Africa (developing only) in 2006 to that in 2007?
Provide a short and direct response. 0.99. What is the ratio of the Electricity production(% of total) in Bangladesh in 2006 to that in 2007?
Offer a terse response. 0.39. What is the ratio of the Electricity production(% of total) in Estonia in 2006 to that in 2007?
Your answer should be very brief. 1.24. What is the ratio of the Electricity production(% of total) of Middle East & North Africa (developing only) in 2006 to that in 2008?
Make the answer very short. 1.26. What is the ratio of the Electricity production(% of total) of Sub-Saharan Africa (developing only) in 2006 to that in 2008?
Your answer should be compact. 1.01. What is the ratio of the Electricity production(% of total) in Bangladesh in 2006 to that in 2008?
Your response must be concise. 0.31. What is the ratio of the Electricity production(% of total) in Estonia in 2006 to that in 2008?
Ensure brevity in your answer.  0.95. What is the ratio of the Electricity production(% of total) in Middle East & North Africa (developing only) in 2006 to that in 2009?
Provide a short and direct response. 1.41. What is the ratio of the Electricity production(% of total) in Sub-Saharan Africa (developing only) in 2006 to that in 2009?
Keep it short and to the point. 1.03. What is the ratio of the Electricity production(% of total) in Bangladesh in 2006 to that in 2009?
Offer a very short reply. 0.34. What is the ratio of the Electricity production(% of total) of Estonia in 2006 to that in 2009?
Offer a very short reply. 0.55. What is the ratio of the Electricity production(% of total) in Middle East & North Africa (developing only) in 2006 to that in 2010?
Offer a terse response. 1.52. What is the ratio of the Electricity production(% of total) of Sub-Saharan Africa (developing only) in 2006 to that in 2010?
Provide a succinct answer. 1.05. What is the ratio of the Electricity production(% of total) of Bangladesh in 2006 to that in 2010?
Your answer should be very brief. 0.54. What is the ratio of the Electricity production(% of total) of Estonia in 2006 to that in 2010?
Your answer should be compact. 0.79. What is the ratio of the Electricity production(% of total) in Middle East & North Africa (developing only) in 2006 to that in 2011?
Offer a terse response. 1.45. What is the ratio of the Electricity production(% of total) of Sub-Saharan Africa (developing only) in 2006 to that in 2011?
Provide a short and direct response. 1.07. What is the ratio of the Electricity production(% of total) in Bangladesh in 2006 to that in 2011?
Your answer should be compact. 0.53. What is the ratio of the Electricity production(% of total) in Estonia in 2006 to that in 2011?
Keep it short and to the point. 0.75. What is the ratio of the Electricity production(% of total) in Middle East & North Africa (developing only) in 2007 to that in 2008?
Keep it short and to the point. 1.15. What is the ratio of the Electricity production(% of total) of Sub-Saharan Africa (developing only) in 2007 to that in 2008?
Your answer should be very brief. 1.01. What is the ratio of the Electricity production(% of total) in Bangladesh in 2007 to that in 2008?
Offer a terse response. 0.79. What is the ratio of the Electricity production(% of total) in Estonia in 2007 to that in 2008?
Give a very brief answer. 0.77. What is the ratio of the Electricity production(% of total) of Middle East & North Africa (developing only) in 2007 to that in 2009?
Ensure brevity in your answer.  1.29. What is the ratio of the Electricity production(% of total) in Bangladesh in 2007 to that in 2009?
Keep it short and to the point. 0.86. What is the ratio of the Electricity production(% of total) of Estonia in 2007 to that in 2009?
Your answer should be very brief. 0.45. What is the ratio of the Electricity production(% of total) of Middle East & North Africa (developing only) in 2007 to that in 2010?
Your answer should be very brief. 1.39. What is the ratio of the Electricity production(% of total) in Sub-Saharan Africa (developing only) in 2007 to that in 2010?
Provide a succinct answer. 1.06. What is the ratio of the Electricity production(% of total) of Bangladesh in 2007 to that in 2010?
Give a very brief answer. 1.37. What is the ratio of the Electricity production(% of total) in Estonia in 2007 to that in 2010?
Ensure brevity in your answer.  0.64. What is the ratio of the Electricity production(% of total) of Middle East & North Africa (developing only) in 2007 to that in 2011?
Offer a very short reply. 1.33. What is the ratio of the Electricity production(% of total) of Sub-Saharan Africa (developing only) in 2007 to that in 2011?
Offer a terse response. 1.07. What is the ratio of the Electricity production(% of total) of Bangladesh in 2007 to that in 2011?
Give a very brief answer. 1.35. What is the ratio of the Electricity production(% of total) in Estonia in 2007 to that in 2011?
Provide a short and direct response. 0.6. What is the ratio of the Electricity production(% of total) in Middle East & North Africa (developing only) in 2008 to that in 2009?
Provide a short and direct response. 1.12. What is the ratio of the Electricity production(% of total) of Sub-Saharan Africa (developing only) in 2008 to that in 2009?
Ensure brevity in your answer.  1.03. What is the ratio of the Electricity production(% of total) of Bangladesh in 2008 to that in 2009?
Your response must be concise. 1.09. What is the ratio of the Electricity production(% of total) in Estonia in 2008 to that in 2009?
Your response must be concise. 0.58. What is the ratio of the Electricity production(% of total) of Middle East & North Africa (developing only) in 2008 to that in 2010?
Your answer should be very brief. 1.21. What is the ratio of the Electricity production(% of total) in Sub-Saharan Africa (developing only) in 2008 to that in 2010?
Provide a short and direct response. 1.04. What is the ratio of the Electricity production(% of total) of Bangladesh in 2008 to that in 2010?
Keep it short and to the point. 1.73. What is the ratio of the Electricity production(% of total) of Estonia in 2008 to that in 2010?
Your answer should be very brief. 0.84. What is the ratio of the Electricity production(% of total) of Middle East & North Africa (developing only) in 2008 to that in 2011?
Give a very brief answer. 1.15. What is the ratio of the Electricity production(% of total) in Sub-Saharan Africa (developing only) in 2008 to that in 2011?
Provide a short and direct response. 1.06. What is the ratio of the Electricity production(% of total) of Bangladesh in 2008 to that in 2011?
Keep it short and to the point. 1.71. What is the ratio of the Electricity production(% of total) in Estonia in 2008 to that in 2011?
Your answer should be compact. 0.79. What is the ratio of the Electricity production(% of total) in Middle East & North Africa (developing only) in 2009 to that in 2010?
Give a very brief answer. 1.08. What is the ratio of the Electricity production(% of total) of Sub-Saharan Africa (developing only) in 2009 to that in 2010?
Your response must be concise. 1.02. What is the ratio of the Electricity production(% of total) in Bangladesh in 2009 to that in 2010?
Your answer should be compact. 1.59. What is the ratio of the Electricity production(% of total) in Estonia in 2009 to that in 2010?
Your response must be concise. 1.44. What is the ratio of the Electricity production(% of total) of Middle East & North Africa (developing only) in 2009 to that in 2011?
Your answer should be compact. 1.02. What is the ratio of the Electricity production(% of total) in Sub-Saharan Africa (developing only) in 2009 to that in 2011?
Your answer should be very brief. 1.03. What is the ratio of the Electricity production(% of total) in Bangladesh in 2009 to that in 2011?
Your answer should be compact. 1.57. What is the ratio of the Electricity production(% of total) of Estonia in 2009 to that in 2011?
Your answer should be compact. 1.35. What is the ratio of the Electricity production(% of total) of Middle East & North Africa (developing only) in 2010 to that in 2011?
Your answer should be compact. 0.95. What is the ratio of the Electricity production(% of total) in Sub-Saharan Africa (developing only) in 2010 to that in 2011?
Your answer should be very brief. 1.01. What is the ratio of the Electricity production(% of total) in Bangladesh in 2010 to that in 2011?
Your answer should be compact. 0.99. What is the ratio of the Electricity production(% of total) of Estonia in 2010 to that in 2011?
Keep it short and to the point. 0.94. What is the difference between the highest and the second highest Electricity production(% of total) of Middle East & North Africa (developing only)?
Keep it short and to the point. 0.23. What is the difference between the highest and the second highest Electricity production(% of total) in Sub-Saharan Africa (developing only)?
Ensure brevity in your answer.  0.33. What is the difference between the highest and the second highest Electricity production(% of total) of Bangladesh?
Your answer should be very brief. 0.25. What is the difference between the highest and the second highest Electricity production(% of total) of Estonia?
Keep it short and to the point. 1.18. What is the difference between the highest and the lowest Electricity production(% of total) in Middle East & North Africa (developing only)?
Ensure brevity in your answer.  0.91. What is the difference between the highest and the lowest Electricity production(% of total) in Sub-Saharan Africa (developing only)?
Your answer should be compact. 4.19. What is the difference between the highest and the lowest Electricity production(% of total) of Bangladesh?
Provide a succinct answer. 2.09. What is the difference between the highest and the lowest Electricity production(% of total) in Estonia?
Your response must be concise. 2.52. 